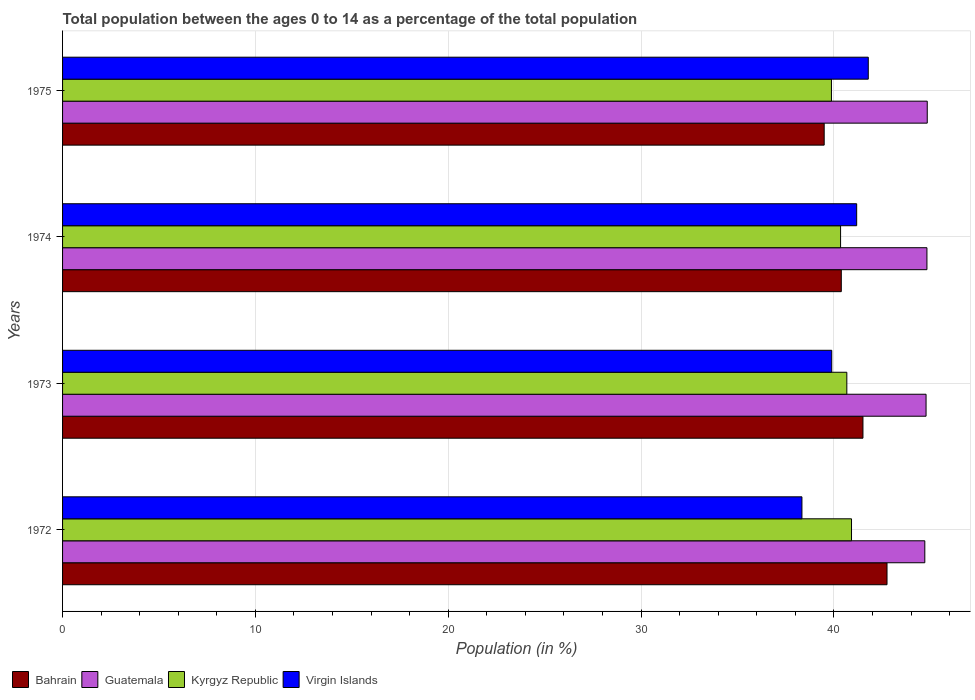How many different coloured bars are there?
Offer a very short reply. 4. Are the number of bars per tick equal to the number of legend labels?
Give a very brief answer. Yes. Are the number of bars on each tick of the Y-axis equal?
Keep it short and to the point. Yes. How many bars are there on the 4th tick from the bottom?
Provide a short and direct response. 4. What is the percentage of the population ages 0 to 14 in Kyrgyz Republic in 1972?
Offer a very short reply. 40.91. Across all years, what is the maximum percentage of the population ages 0 to 14 in Kyrgyz Republic?
Your response must be concise. 40.91. Across all years, what is the minimum percentage of the population ages 0 to 14 in Bahrain?
Ensure brevity in your answer.  39.49. In which year was the percentage of the population ages 0 to 14 in Virgin Islands maximum?
Ensure brevity in your answer.  1975. In which year was the percentage of the population ages 0 to 14 in Bahrain minimum?
Your answer should be very brief. 1975. What is the total percentage of the population ages 0 to 14 in Kyrgyz Republic in the graph?
Your response must be concise. 161.79. What is the difference between the percentage of the population ages 0 to 14 in Guatemala in 1972 and that in 1974?
Give a very brief answer. -0.11. What is the difference between the percentage of the population ages 0 to 14 in Kyrgyz Republic in 1974 and the percentage of the population ages 0 to 14 in Virgin Islands in 1972?
Your answer should be very brief. 2. What is the average percentage of the population ages 0 to 14 in Virgin Islands per year?
Your answer should be compact. 40.3. In the year 1973, what is the difference between the percentage of the population ages 0 to 14 in Kyrgyz Republic and percentage of the population ages 0 to 14 in Bahrain?
Make the answer very short. -0.84. In how many years, is the percentage of the population ages 0 to 14 in Kyrgyz Republic greater than 42 ?
Give a very brief answer. 0. What is the ratio of the percentage of the population ages 0 to 14 in Bahrain in 1973 to that in 1974?
Your answer should be compact. 1.03. What is the difference between the highest and the second highest percentage of the population ages 0 to 14 in Virgin Islands?
Provide a succinct answer. 0.6. What is the difference between the highest and the lowest percentage of the population ages 0 to 14 in Guatemala?
Offer a terse response. 0.13. In how many years, is the percentage of the population ages 0 to 14 in Virgin Islands greater than the average percentage of the population ages 0 to 14 in Virgin Islands taken over all years?
Give a very brief answer. 2. Is the sum of the percentage of the population ages 0 to 14 in Bahrain in 1972 and 1974 greater than the maximum percentage of the population ages 0 to 14 in Guatemala across all years?
Offer a very short reply. Yes. Is it the case that in every year, the sum of the percentage of the population ages 0 to 14 in Guatemala and percentage of the population ages 0 to 14 in Bahrain is greater than the sum of percentage of the population ages 0 to 14 in Virgin Islands and percentage of the population ages 0 to 14 in Kyrgyz Republic?
Your answer should be very brief. Yes. What does the 1st bar from the top in 1973 represents?
Offer a terse response. Virgin Islands. What does the 1st bar from the bottom in 1974 represents?
Your answer should be compact. Bahrain. How many bars are there?
Offer a very short reply. 16. Are all the bars in the graph horizontal?
Provide a short and direct response. Yes. How many years are there in the graph?
Your answer should be compact. 4. What is the difference between two consecutive major ticks on the X-axis?
Provide a short and direct response. 10. Are the values on the major ticks of X-axis written in scientific E-notation?
Your response must be concise. No. Does the graph contain grids?
Ensure brevity in your answer.  Yes. Where does the legend appear in the graph?
Offer a terse response. Bottom left. How are the legend labels stacked?
Your response must be concise. Horizontal. What is the title of the graph?
Offer a very short reply. Total population between the ages 0 to 14 as a percentage of the total population. Does "Pakistan" appear as one of the legend labels in the graph?
Keep it short and to the point. No. What is the label or title of the X-axis?
Your response must be concise. Population (in %). What is the Population (in %) of Bahrain in 1972?
Make the answer very short. 42.75. What is the Population (in %) of Guatemala in 1972?
Provide a short and direct response. 44.71. What is the Population (in %) of Kyrgyz Republic in 1972?
Give a very brief answer. 40.91. What is the Population (in %) in Virgin Islands in 1972?
Keep it short and to the point. 38.34. What is the Population (in %) in Bahrain in 1973?
Provide a succinct answer. 41.5. What is the Population (in %) in Guatemala in 1973?
Offer a terse response. 44.78. What is the Population (in %) of Kyrgyz Republic in 1973?
Make the answer very short. 40.67. What is the Population (in %) of Virgin Islands in 1973?
Your answer should be compact. 39.88. What is the Population (in %) in Bahrain in 1974?
Offer a very short reply. 40.38. What is the Population (in %) of Guatemala in 1974?
Provide a succinct answer. 44.82. What is the Population (in %) in Kyrgyz Republic in 1974?
Your answer should be very brief. 40.34. What is the Population (in %) of Virgin Islands in 1974?
Offer a terse response. 41.18. What is the Population (in %) of Bahrain in 1975?
Your response must be concise. 39.49. What is the Population (in %) of Guatemala in 1975?
Provide a short and direct response. 44.84. What is the Population (in %) of Kyrgyz Republic in 1975?
Your answer should be compact. 39.87. What is the Population (in %) in Virgin Islands in 1975?
Offer a terse response. 41.78. Across all years, what is the maximum Population (in %) of Bahrain?
Ensure brevity in your answer.  42.75. Across all years, what is the maximum Population (in %) in Guatemala?
Offer a very short reply. 44.84. Across all years, what is the maximum Population (in %) in Kyrgyz Republic?
Ensure brevity in your answer.  40.91. Across all years, what is the maximum Population (in %) of Virgin Islands?
Provide a succinct answer. 41.78. Across all years, what is the minimum Population (in %) of Bahrain?
Give a very brief answer. 39.49. Across all years, what is the minimum Population (in %) of Guatemala?
Offer a very short reply. 44.71. Across all years, what is the minimum Population (in %) in Kyrgyz Republic?
Give a very brief answer. 39.87. Across all years, what is the minimum Population (in %) of Virgin Islands?
Give a very brief answer. 38.34. What is the total Population (in %) in Bahrain in the graph?
Your answer should be very brief. 164.13. What is the total Population (in %) of Guatemala in the graph?
Your answer should be compact. 179.14. What is the total Population (in %) in Kyrgyz Republic in the graph?
Your response must be concise. 161.79. What is the total Population (in %) in Virgin Islands in the graph?
Your response must be concise. 161.18. What is the difference between the Population (in %) of Bahrain in 1972 and that in 1973?
Offer a very short reply. 1.25. What is the difference between the Population (in %) in Guatemala in 1972 and that in 1973?
Give a very brief answer. -0.06. What is the difference between the Population (in %) in Kyrgyz Republic in 1972 and that in 1973?
Provide a succinct answer. 0.24. What is the difference between the Population (in %) in Virgin Islands in 1972 and that in 1973?
Your answer should be very brief. -1.55. What is the difference between the Population (in %) of Bahrain in 1972 and that in 1974?
Offer a terse response. 2.37. What is the difference between the Population (in %) in Guatemala in 1972 and that in 1974?
Your answer should be compact. -0.11. What is the difference between the Population (in %) in Kyrgyz Republic in 1972 and that in 1974?
Provide a short and direct response. 0.57. What is the difference between the Population (in %) in Virgin Islands in 1972 and that in 1974?
Offer a terse response. -2.84. What is the difference between the Population (in %) in Bahrain in 1972 and that in 1975?
Your answer should be very brief. 3.26. What is the difference between the Population (in %) in Guatemala in 1972 and that in 1975?
Your response must be concise. -0.13. What is the difference between the Population (in %) in Kyrgyz Republic in 1972 and that in 1975?
Give a very brief answer. 1.04. What is the difference between the Population (in %) in Virgin Islands in 1972 and that in 1975?
Offer a very short reply. -3.44. What is the difference between the Population (in %) in Bahrain in 1973 and that in 1974?
Make the answer very short. 1.12. What is the difference between the Population (in %) in Guatemala in 1973 and that in 1974?
Offer a very short reply. -0.05. What is the difference between the Population (in %) in Kyrgyz Republic in 1973 and that in 1974?
Your answer should be very brief. 0.32. What is the difference between the Population (in %) in Virgin Islands in 1973 and that in 1974?
Provide a succinct answer. -1.29. What is the difference between the Population (in %) in Bahrain in 1973 and that in 1975?
Your answer should be compact. 2.01. What is the difference between the Population (in %) of Guatemala in 1973 and that in 1975?
Your answer should be very brief. -0.06. What is the difference between the Population (in %) of Kyrgyz Republic in 1973 and that in 1975?
Your response must be concise. 0.8. What is the difference between the Population (in %) in Virgin Islands in 1973 and that in 1975?
Give a very brief answer. -1.89. What is the difference between the Population (in %) in Bahrain in 1974 and that in 1975?
Ensure brevity in your answer.  0.89. What is the difference between the Population (in %) in Guatemala in 1974 and that in 1975?
Your response must be concise. -0.02. What is the difference between the Population (in %) of Kyrgyz Republic in 1974 and that in 1975?
Offer a terse response. 0.47. What is the difference between the Population (in %) of Virgin Islands in 1974 and that in 1975?
Offer a very short reply. -0.6. What is the difference between the Population (in %) of Bahrain in 1972 and the Population (in %) of Guatemala in 1973?
Provide a succinct answer. -2.02. What is the difference between the Population (in %) of Bahrain in 1972 and the Population (in %) of Kyrgyz Republic in 1973?
Offer a terse response. 2.08. What is the difference between the Population (in %) in Bahrain in 1972 and the Population (in %) in Virgin Islands in 1973?
Give a very brief answer. 2.87. What is the difference between the Population (in %) in Guatemala in 1972 and the Population (in %) in Kyrgyz Republic in 1973?
Offer a terse response. 4.04. What is the difference between the Population (in %) of Guatemala in 1972 and the Population (in %) of Virgin Islands in 1973?
Ensure brevity in your answer.  4.83. What is the difference between the Population (in %) in Kyrgyz Republic in 1972 and the Population (in %) in Virgin Islands in 1973?
Offer a very short reply. 1.02. What is the difference between the Population (in %) in Bahrain in 1972 and the Population (in %) in Guatemala in 1974?
Ensure brevity in your answer.  -2.07. What is the difference between the Population (in %) of Bahrain in 1972 and the Population (in %) of Kyrgyz Republic in 1974?
Provide a succinct answer. 2.41. What is the difference between the Population (in %) of Bahrain in 1972 and the Population (in %) of Virgin Islands in 1974?
Your answer should be very brief. 1.57. What is the difference between the Population (in %) in Guatemala in 1972 and the Population (in %) in Kyrgyz Republic in 1974?
Make the answer very short. 4.37. What is the difference between the Population (in %) of Guatemala in 1972 and the Population (in %) of Virgin Islands in 1974?
Provide a succinct answer. 3.53. What is the difference between the Population (in %) of Kyrgyz Republic in 1972 and the Population (in %) of Virgin Islands in 1974?
Keep it short and to the point. -0.27. What is the difference between the Population (in %) in Bahrain in 1972 and the Population (in %) in Guatemala in 1975?
Make the answer very short. -2.09. What is the difference between the Population (in %) of Bahrain in 1972 and the Population (in %) of Kyrgyz Republic in 1975?
Offer a very short reply. 2.88. What is the difference between the Population (in %) of Bahrain in 1972 and the Population (in %) of Virgin Islands in 1975?
Your response must be concise. 0.97. What is the difference between the Population (in %) of Guatemala in 1972 and the Population (in %) of Kyrgyz Republic in 1975?
Your answer should be very brief. 4.84. What is the difference between the Population (in %) in Guatemala in 1972 and the Population (in %) in Virgin Islands in 1975?
Make the answer very short. 2.93. What is the difference between the Population (in %) of Kyrgyz Republic in 1972 and the Population (in %) of Virgin Islands in 1975?
Provide a short and direct response. -0.87. What is the difference between the Population (in %) of Bahrain in 1973 and the Population (in %) of Guatemala in 1974?
Your response must be concise. -3.32. What is the difference between the Population (in %) in Bahrain in 1973 and the Population (in %) in Kyrgyz Republic in 1974?
Your response must be concise. 1.16. What is the difference between the Population (in %) in Bahrain in 1973 and the Population (in %) in Virgin Islands in 1974?
Keep it short and to the point. 0.33. What is the difference between the Population (in %) of Guatemala in 1973 and the Population (in %) of Kyrgyz Republic in 1974?
Your answer should be compact. 4.43. What is the difference between the Population (in %) of Guatemala in 1973 and the Population (in %) of Virgin Islands in 1974?
Keep it short and to the point. 3.6. What is the difference between the Population (in %) in Kyrgyz Republic in 1973 and the Population (in %) in Virgin Islands in 1974?
Offer a terse response. -0.51. What is the difference between the Population (in %) in Bahrain in 1973 and the Population (in %) in Guatemala in 1975?
Your answer should be very brief. -3.33. What is the difference between the Population (in %) in Bahrain in 1973 and the Population (in %) in Kyrgyz Republic in 1975?
Give a very brief answer. 1.63. What is the difference between the Population (in %) of Bahrain in 1973 and the Population (in %) of Virgin Islands in 1975?
Give a very brief answer. -0.28. What is the difference between the Population (in %) of Guatemala in 1973 and the Population (in %) of Kyrgyz Republic in 1975?
Keep it short and to the point. 4.91. What is the difference between the Population (in %) in Guatemala in 1973 and the Population (in %) in Virgin Islands in 1975?
Provide a succinct answer. 3. What is the difference between the Population (in %) of Kyrgyz Republic in 1973 and the Population (in %) of Virgin Islands in 1975?
Offer a very short reply. -1.11. What is the difference between the Population (in %) of Bahrain in 1974 and the Population (in %) of Guatemala in 1975?
Your response must be concise. -4.46. What is the difference between the Population (in %) in Bahrain in 1974 and the Population (in %) in Kyrgyz Republic in 1975?
Your answer should be compact. 0.51. What is the difference between the Population (in %) in Bahrain in 1974 and the Population (in %) in Virgin Islands in 1975?
Your answer should be very brief. -1.4. What is the difference between the Population (in %) of Guatemala in 1974 and the Population (in %) of Kyrgyz Republic in 1975?
Ensure brevity in your answer.  4.95. What is the difference between the Population (in %) in Guatemala in 1974 and the Population (in %) in Virgin Islands in 1975?
Your response must be concise. 3.04. What is the difference between the Population (in %) in Kyrgyz Republic in 1974 and the Population (in %) in Virgin Islands in 1975?
Offer a very short reply. -1.44. What is the average Population (in %) of Bahrain per year?
Offer a terse response. 41.03. What is the average Population (in %) of Guatemala per year?
Keep it short and to the point. 44.79. What is the average Population (in %) of Kyrgyz Republic per year?
Your answer should be very brief. 40.45. What is the average Population (in %) of Virgin Islands per year?
Your answer should be compact. 40.3. In the year 1972, what is the difference between the Population (in %) in Bahrain and Population (in %) in Guatemala?
Offer a terse response. -1.96. In the year 1972, what is the difference between the Population (in %) of Bahrain and Population (in %) of Kyrgyz Republic?
Your answer should be compact. 1.84. In the year 1972, what is the difference between the Population (in %) of Bahrain and Population (in %) of Virgin Islands?
Your answer should be compact. 4.41. In the year 1972, what is the difference between the Population (in %) of Guatemala and Population (in %) of Kyrgyz Republic?
Offer a very short reply. 3.8. In the year 1972, what is the difference between the Population (in %) of Guatemala and Population (in %) of Virgin Islands?
Make the answer very short. 6.37. In the year 1972, what is the difference between the Population (in %) in Kyrgyz Republic and Population (in %) in Virgin Islands?
Your answer should be compact. 2.57. In the year 1973, what is the difference between the Population (in %) in Bahrain and Population (in %) in Guatemala?
Your response must be concise. -3.27. In the year 1973, what is the difference between the Population (in %) in Bahrain and Population (in %) in Kyrgyz Republic?
Your answer should be compact. 0.84. In the year 1973, what is the difference between the Population (in %) in Bahrain and Population (in %) in Virgin Islands?
Offer a terse response. 1.62. In the year 1973, what is the difference between the Population (in %) in Guatemala and Population (in %) in Kyrgyz Republic?
Provide a succinct answer. 4.11. In the year 1973, what is the difference between the Population (in %) in Guatemala and Population (in %) in Virgin Islands?
Offer a very short reply. 4.89. In the year 1973, what is the difference between the Population (in %) in Kyrgyz Republic and Population (in %) in Virgin Islands?
Your answer should be compact. 0.78. In the year 1974, what is the difference between the Population (in %) in Bahrain and Population (in %) in Guatemala?
Provide a succinct answer. -4.44. In the year 1974, what is the difference between the Population (in %) of Bahrain and Population (in %) of Kyrgyz Republic?
Ensure brevity in your answer.  0.04. In the year 1974, what is the difference between the Population (in %) in Bahrain and Population (in %) in Virgin Islands?
Your answer should be very brief. -0.8. In the year 1974, what is the difference between the Population (in %) of Guatemala and Population (in %) of Kyrgyz Republic?
Make the answer very short. 4.48. In the year 1974, what is the difference between the Population (in %) of Guatemala and Population (in %) of Virgin Islands?
Provide a succinct answer. 3.64. In the year 1974, what is the difference between the Population (in %) in Kyrgyz Republic and Population (in %) in Virgin Islands?
Keep it short and to the point. -0.84. In the year 1975, what is the difference between the Population (in %) of Bahrain and Population (in %) of Guatemala?
Give a very brief answer. -5.34. In the year 1975, what is the difference between the Population (in %) of Bahrain and Population (in %) of Kyrgyz Republic?
Offer a very short reply. -0.38. In the year 1975, what is the difference between the Population (in %) in Bahrain and Population (in %) in Virgin Islands?
Give a very brief answer. -2.29. In the year 1975, what is the difference between the Population (in %) in Guatemala and Population (in %) in Kyrgyz Republic?
Offer a terse response. 4.97. In the year 1975, what is the difference between the Population (in %) of Guatemala and Population (in %) of Virgin Islands?
Ensure brevity in your answer.  3.06. In the year 1975, what is the difference between the Population (in %) in Kyrgyz Republic and Population (in %) in Virgin Islands?
Keep it short and to the point. -1.91. What is the ratio of the Population (in %) in Bahrain in 1972 to that in 1973?
Provide a succinct answer. 1.03. What is the ratio of the Population (in %) in Kyrgyz Republic in 1972 to that in 1973?
Offer a terse response. 1.01. What is the ratio of the Population (in %) in Virgin Islands in 1972 to that in 1973?
Provide a succinct answer. 0.96. What is the ratio of the Population (in %) of Bahrain in 1972 to that in 1974?
Ensure brevity in your answer.  1.06. What is the ratio of the Population (in %) of Kyrgyz Republic in 1972 to that in 1974?
Provide a succinct answer. 1.01. What is the ratio of the Population (in %) of Virgin Islands in 1972 to that in 1974?
Give a very brief answer. 0.93. What is the ratio of the Population (in %) in Bahrain in 1972 to that in 1975?
Offer a terse response. 1.08. What is the ratio of the Population (in %) in Kyrgyz Republic in 1972 to that in 1975?
Provide a succinct answer. 1.03. What is the ratio of the Population (in %) in Virgin Islands in 1972 to that in 1975?
Make the answer very short. 0.92. What is the ratio of the Population (in %) of Bahrain in 1973 to that in 1974?
Offer a very short reply. 1.03. What is the ratio of the Population (in %) in Guatemala in 1973 to that in 1974?
Give a very brief answer. 1. What is the ratio of the Population (in %) in Virgin Islands in 1973 to that in 1974?
Your answer should be compact. 0.97. What is the ratio of the Population (in %) of Bahrain in 1973 to that in 1975?
Ensure brevity in your answer.  1.05. What is the ratio of the Population (in %) in Virgin Islands in 1973 to that in 1975?
Your response must be concise. 0.95. What is the ratio of the Population (in %) of Bahrain in 1974 to that in 1975?
Your answer should be compact. 1.02. What is the ratio of the Population (in %) in Kyrgyz Republic in 1974 to that in 1975?
Give a very brief answer. 1.01. What is the ratio of the Population (in %) of Virgin Islands in 1974 to that in 1975?
Your response must be concise. 0.99. What is the difference between the highest and the second highest Population (in %) of Bahrain?
Provide a short and direct response. 1.25. What is the difference between the highest and the second highest Population (in %) in Guatemala?
Give a very brief answer. 0.02. What is the difference between the highest and the second highest Population (in %) of Kyrgyz Republic?
Your answer should be compact. 0.24. What is the difference between the highest and the second highest Population (in %) in Virgin Islands?
Ensure brevity in your answer.  0.6. What is the difference between the highest and the lowest Population (in %) of Bahrain?
Your answer should be very brief. 3.26. What is the difference between the highest and the lowest Population (in %) of Guatemala?
Provide a short and direct response. 0.13. What is the difference between the highest and the lowest Population (in %) in Kyrgyz Republic?
Your answer should be very brief. 1.04. What is the difference between the highest and the lowest Population (in %) of Virgin Islands?
Provide a short and direct response. 3.44. 